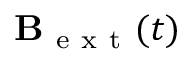<formula> <loc_0><loc_0><loc_500><loc_500>B _ { e x t } ( t )</formula> 